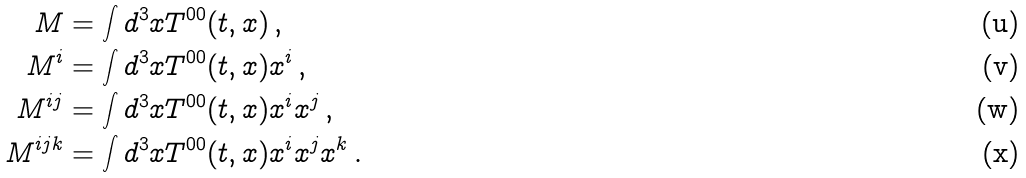<formula> <loc_0><loc_0><loc_500><loc_500>M & = \int d ^ { 3 } x T ^ { 0 0 } ( t , x ) \, , \\ M ^ { i } & = \int d ^ { 3 } x T ^ { 0 0 } ( t , x ) x ^ { i } \, , \\ M ^ { i j } & = \int d ^ { 3 } x T ^ { 0 0 } ( t , x ) x ^ { i } x ^ { j } \, , \\ M ^ { i j k } & = \int d ^ { 3 } x T ^ { 0 0 } ( t , x ) x ^ { i } x ^ { j } x ^ { k } \, .</formula> 